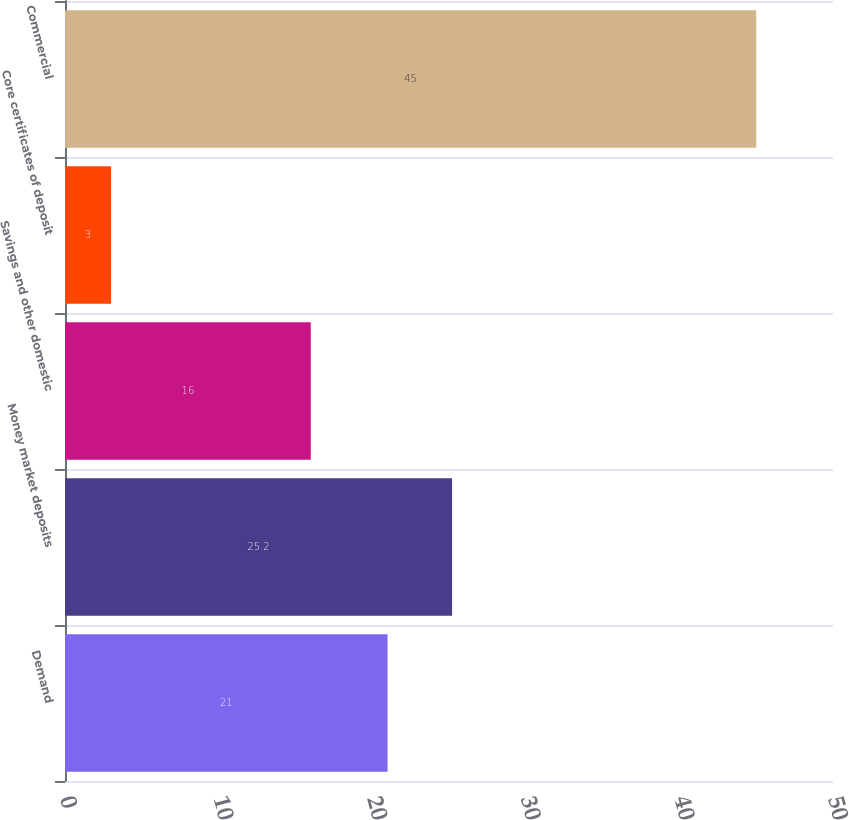Convert chart to OTSL. <chart><loc_0><loc_0><loc_500><loc_500><bar_chart><fcel>Demand<fcel>Money market deposits<fcel>Savings and other domestic<fcel>Core certificates of deposit<fcel>Commercial<nl><fcel>21<fcel>25.2<fcel>16<fcel>3<fcel>45<nl></chart> 